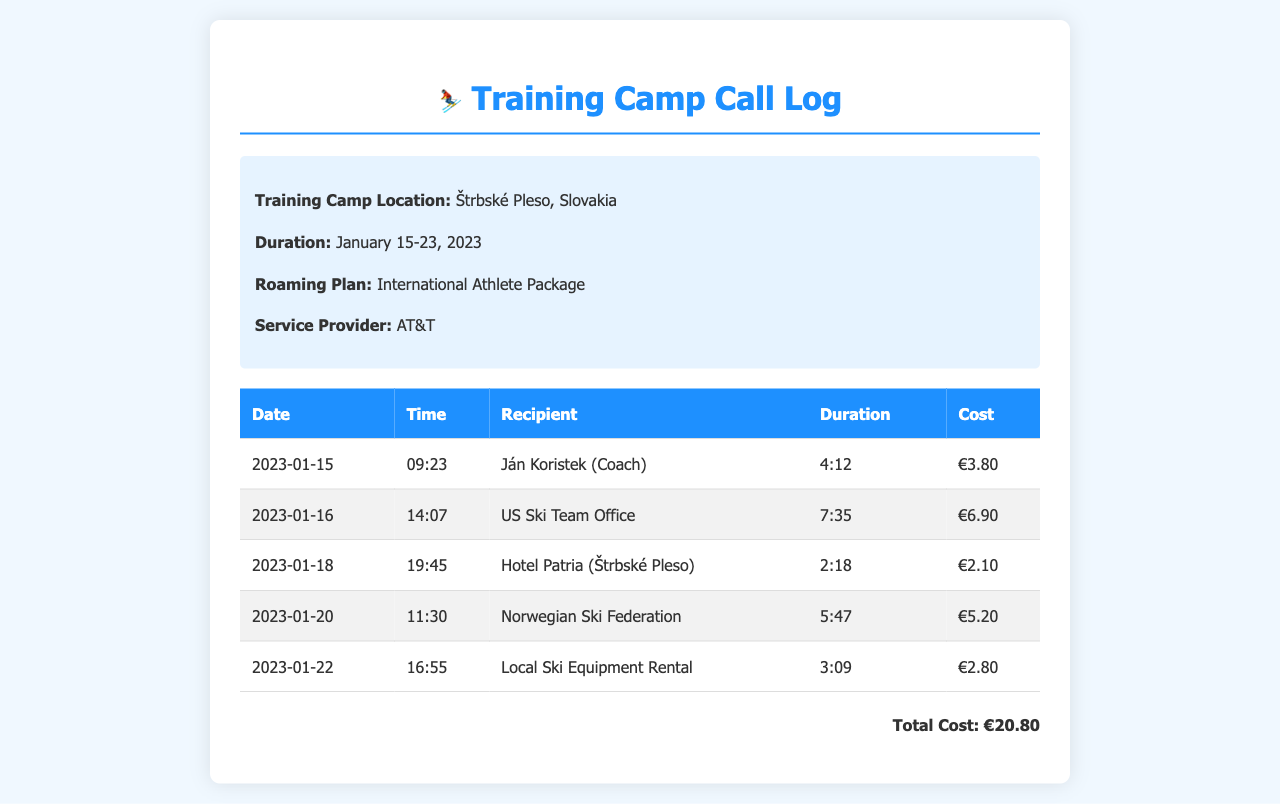What is the training camp location? The training camp is located at Štrbské Pleso, Slovakia, as stated in the information section of the document.
Answer: Štrbské Pleso, Slovakia What is the total cost of the calls? The total cost is summed up at the bottom of the document as €20.80 from the individual call costs listed.
Answer: €20.80 How long was the longest call? The longest call duration can be identified from the call records, which shows that the longest call was for 7 minutes and 35 seconds.
Answer: 7:35 Who was called on January 18, 2023? The recipient of the call on this date is provided in the call records, showing it was to Hotel Patria.
Answer: Hotel Patria (Štrbské Pleso) How many calls were made in total? By counting the entries in the call log table, there are a total of five calls listed during the training camp.
Answer: 5 What service provider was used for the calls? The document explicitly mentions the service provider used during the training camp, which is AT&T.
Answer: AT&T What day did the call to the US Ski Team Office take place? The date of the call can be extracted from the call log, indicating January 16, 2023.
Answer: January 16, 2023 What is the duration of the call to Ján Koristek? The call duration to Ján Koristek is noted in the document as 4 minutes and 12 seconds.
Answer: 4:12 What is the date of the call with the Local Ski Equipment Rental? The date of the call can be found in the records, which is January 22, 2023.
Answer: January 22, 2023 